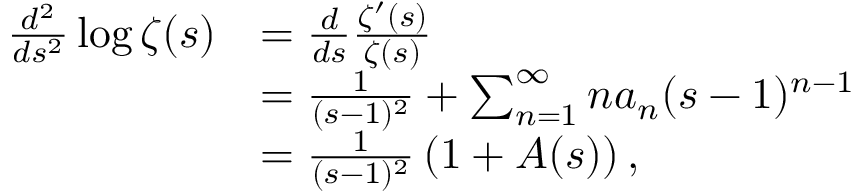<formula> <loc_0><loc_0><loc_500><loc_500>\begin{array} { r l } { \frac { d ^ { 2 } } { d s ^ { 2 } } \log \zeta ( s ) } & { = \frac { d } { d s } \frac { \zeta ^ { \prime } ( s ) } { \zeta ( s ) } } \\ & { = \frac { 1 } { ( s - 1 ) ^ { 2 } } + \sum _ { n = 1 } ^ { \infty } n a _ { n } ( s - 1 ) ^ { n - 1 } } \\ & { = \frac { 1 } { ( s - 1 ) ^ { 2 } } \left ( 1 + A ( s ) \right ) , } \end{array}</formula> 